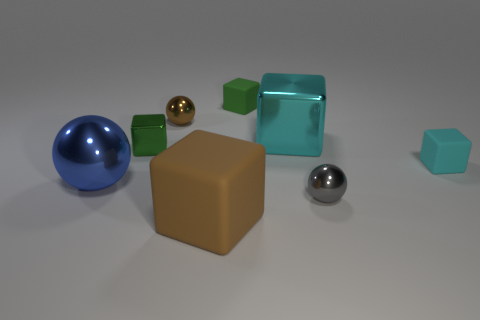What number of small green blocks are to the right of the matte block that is in front of the metal ball to the right of the large cyan shiny block?
Offer a terse response. 1. What size is the cyan block that is made of the same material as the big ball?
Your answer should be very brief. Large. How many shiny balls have the same color as the large matte block?
Offer a terse response. 1. There is a cyan object behind the cyan matte cube; is it the same size as the large brown object?
Make the answer very short. Yes. What is the color of the tiny thing that is both behind the small gray sphere and on the right side of the large cyan cube?
Make the answer very short. Cyan. How many objects are large shiny blocks or tiny things behind the cyan shiny object?
Make the answer very short. 3. What is the material of the green cube that is behind the tiny green object that is in front of the tiny block that is behind the big cyan shiny thing?
Ensure brevity in your answer.  Rubber. There is a ball that is behind the small green metallic cube; is it the same color as the large ball?
Your response must be concise. No. What number of cyan things are big matte blocks or small shiny things?
Give a very brief answer. 0. What number of other things are the same shape as the small green shiny object?
Keep it short and to the point. 4. 